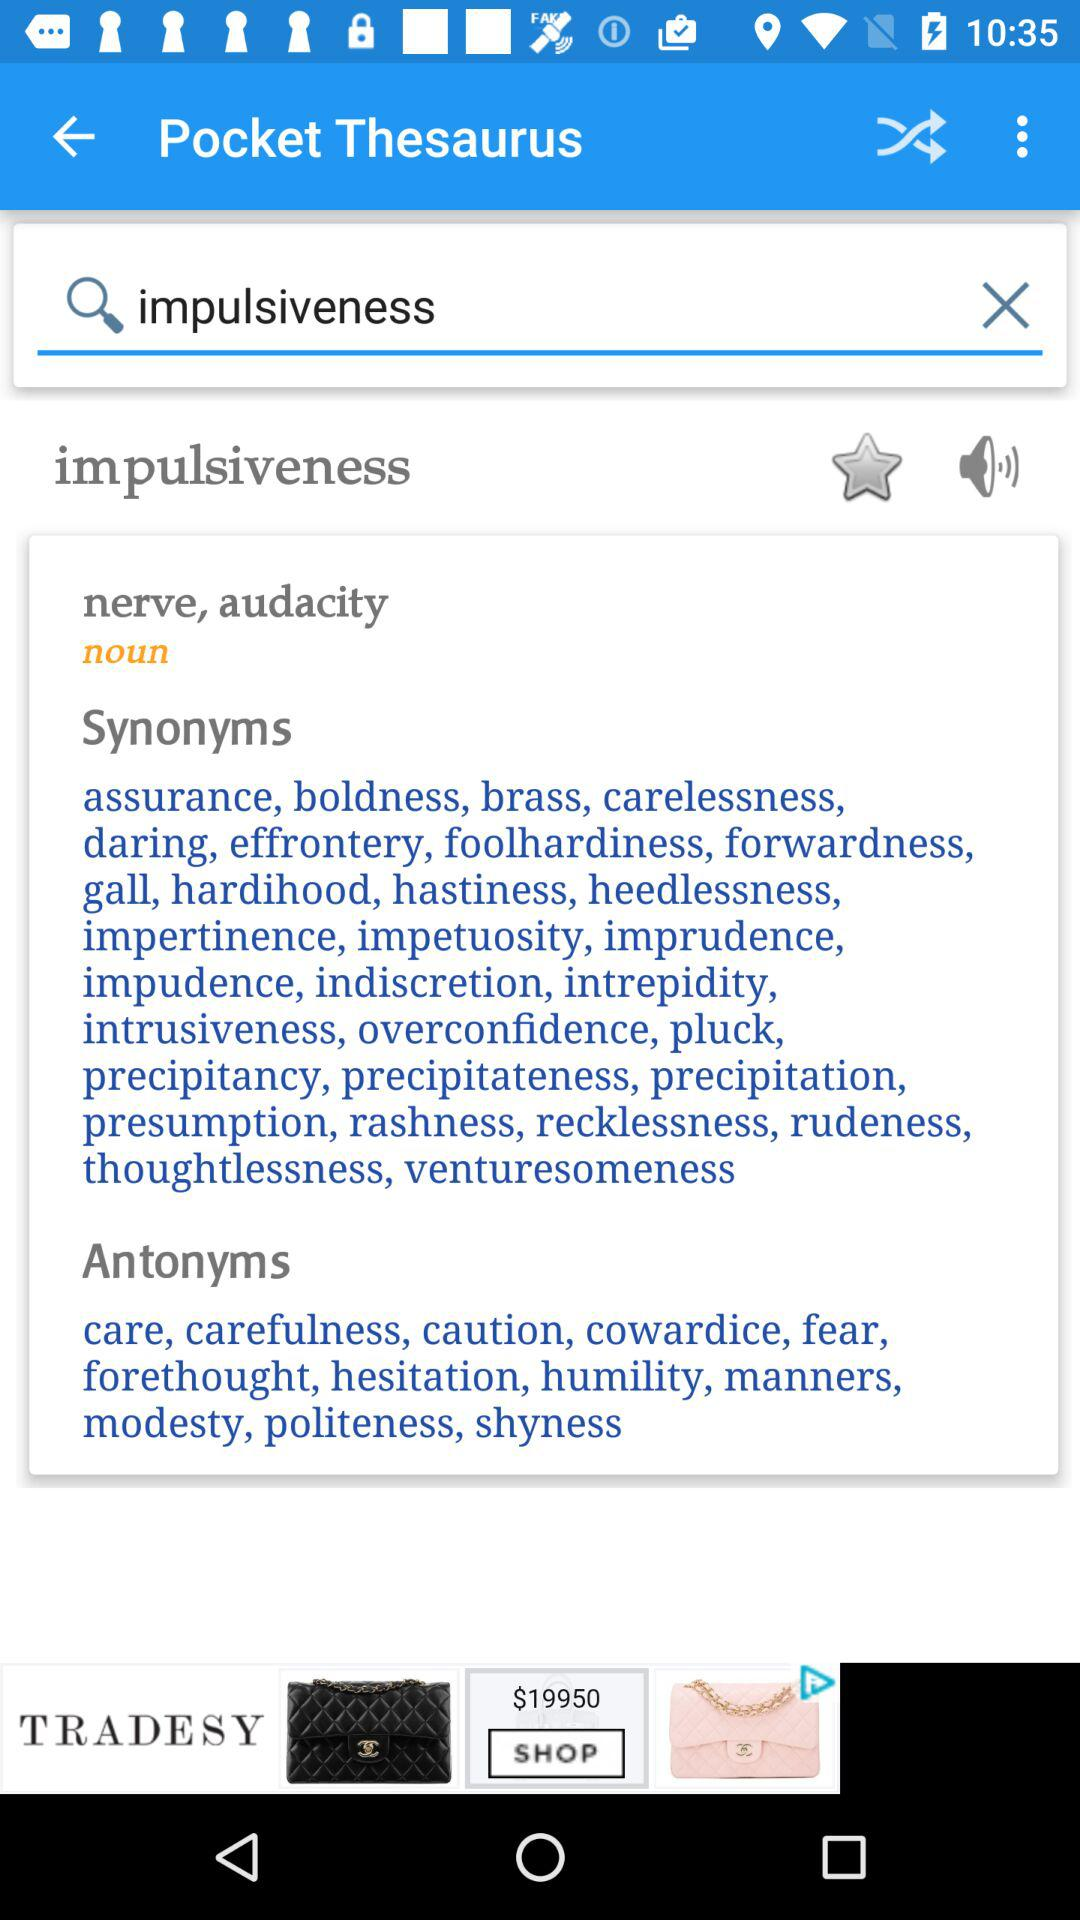What is the application name? The application name is "Pocket Thesaurus". 